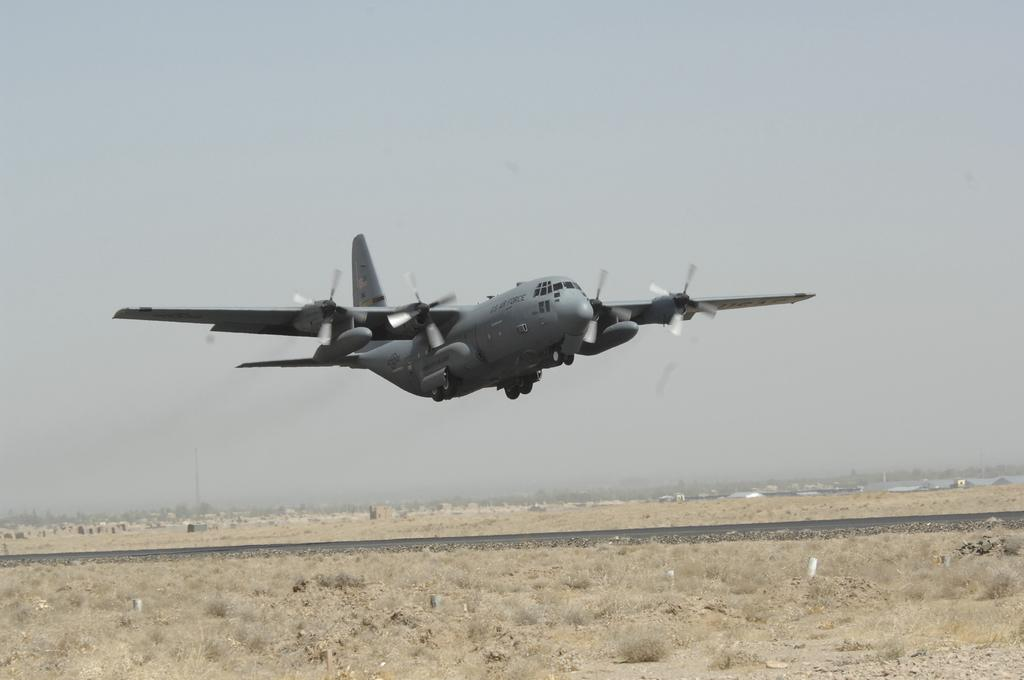What is the main subject of the image? The main subject of the image is an aircraft flying. What type of terrain can be seen in the image? There is grass visible in the image. What is visible in the background of the image? The sky is visible in the background of the image. What type of guitar is being played in the image? There is no guitar present in the image; it features an aircraft flying over grass with the sky visible in the background. 